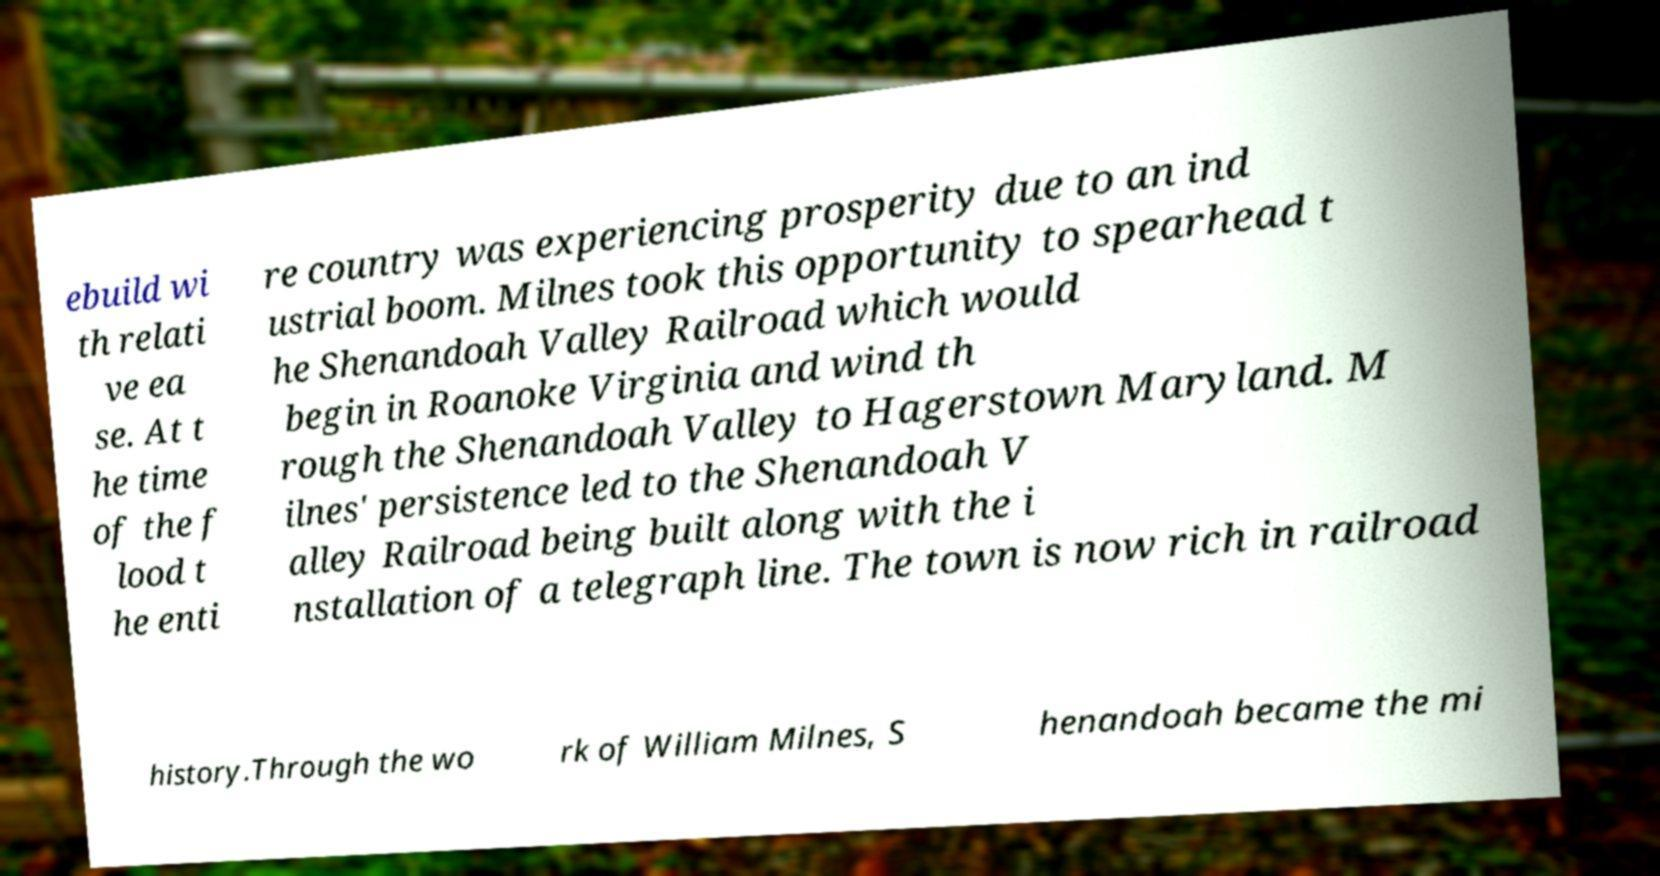I need the written content from this picture converted into text. Can you do that? ebuild wi th relati ve ea se. At t he time of the f lood t he enti re country was experiencing prosperity due to an ind ustrial boom. Milnes took this opportunity to spearhead t he Shenandoah Valley Railroad which would begin in Roanoke Virginia and wind th rough the Shenandoah Valley to Hagerstown Maryland. M ilnes' persistence led to the Shenandoah V alley Railroad being built along with the i nstallation of a telegraph line. The town is now rich in railroad history.Through the wo rk of William Milnes, S henandoah became the mi 